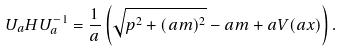Convert formula to latex. <formula><loc_0><loc_0><loc_500><loc_500>U _ { a } H U _ { a } ^ { - 1 } = \frac { 1 } { a } \left ( \sqrt { p ^ { 2 } + ( a m ) ^ { 2 } } - a m + a V ( a x ) \right ) .</formula> 